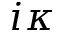Convert formula to latex. <formula><loc_0><loc_0><loc_500><loc_500>i \kappa</formula> 